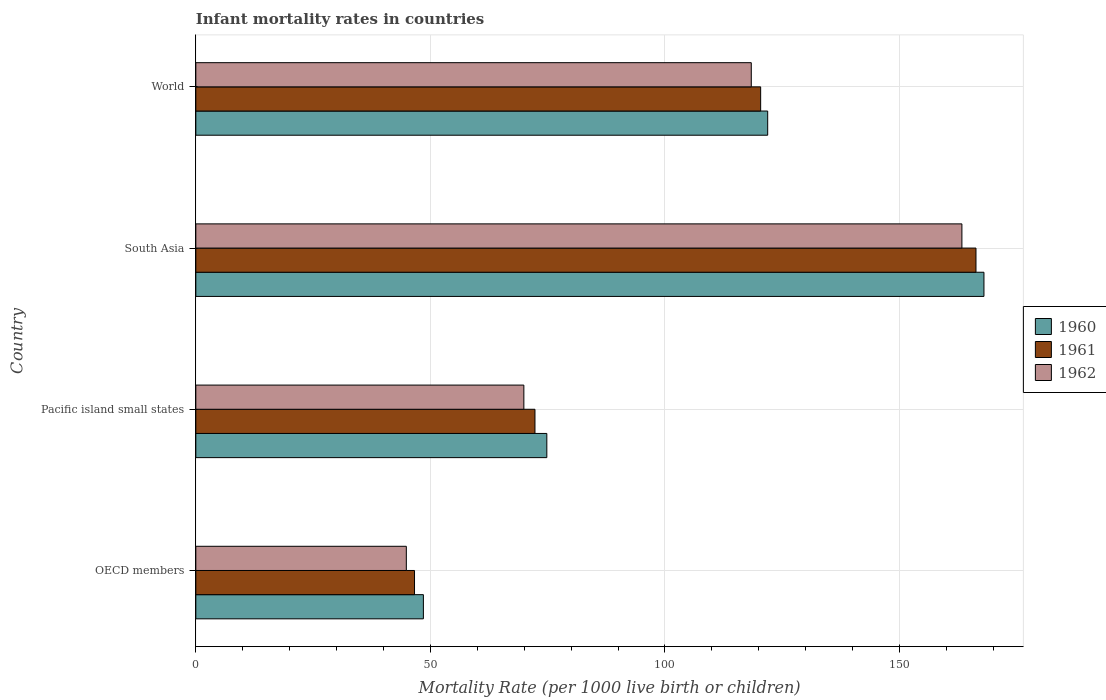How many different coloured bars are there?
Your answer should be compact. 3. How many groups of bars are there?
Ensure brevity in your answer.  4. Are the number of bars per tick equal to the number of legend labels?
Make the answer very short. Yes. How many bars are there on the 4th tick from the bottom?
Keep it short and to the point. 3. What is the label of the 4th group of bars from the top?
Make the answer very short. OECD members. What is the infant mortality rate in 1962 in World?
Provide a succinct answer. 118.4. Across all countries, what is the maximum infant mortality rate in 1960?
Your response must be concise. 168. Across all countries, what is the minimum infant mortality rate in 1960?
Your response must be concise. 48.51. In which country was the infant mortality rate in 1962 maximum?
Your answer should be compact. South Asia. In which country was the infant mortality rate in 1961 minimum?
Keep it short and to the point. OECD members. What is the total infant mortality rate in 1962 in the graph?
Offer a very short reply. 396.5. What is the difference between the infant mortality rate in 1960 in OECD members and that in South Asia?
Your response must be concise. -119.49. What is the difference between the infant mortality rate in 1960 in Pacific island small states and the infant mortality rate in 1961 in World?
Offer a terse response. -45.58. What is the average infant mortality rate in 1961 per country?
Offer a terse response. 101.4. What is the ratio of the infant mortality rate in 1961 in OECD members to that in Pacific island small states?
Offer a terse response. 0.64. What is the difference between the highest and the second highest infant mortality rate in 1962?
Provide a succinct answer. 44.9. What is the difference between the highest and the lowest infant mortality rate in 1960?
Ensure brevity in your answer.  119.49. In how many countries, is the infant mortality rate in 1961 greater than the average infant mortality rate in 1961 taken over all countries?
Offer a terse response. 2. What does the 2nd bar from the top in Pacific island small states represents?
Your answer should be very brief. 1961. Is it the case that in every country, the sum of the infant mortality rate in 1961 and infant mortality rate in 1962 is greater than the infant mortality rate in 1960?
Ensure brevity in your answer.  Yes. Are all the bars in the graph horizontal?
Provide a succinct answer. Yes. How many countries are there in the graph?
Offer a very short reply. 4. Does the graph contain any zero values?
Keep it short and to the point. No. How are the legend labels stacked?
Provide a short and direct response. Vertical. What is the title of the graph?
Your response must be concise. Infant mortality rates in countries. Does "1976" appear as one of the legend labels in the graph?
Offer a terse response. No. What is the label or title of the X-axis?
Provide a succinct answer. Mortality Rate (per 1000 live birth or children). What is the label or title of the Y-axis?
Your answer should be very brief. Country. What is the Mortality Rate (per 1000 live birth or children) in 1960 in OECD members?
Ensure brevity in your answer.  48.51. What is the Mortality Rate (per 1000 live birth or children) of 1961 in OECD members?
Offer a terse response. 46.61. What is the Mortality Rate (per 1000 live birth or children) of 1962 in OECD members?
Your response must be concise. 44.87. What is the Mortality Rate (per 1000 live birth or children) of 1960 in Pacific island small states?
Provide a short and direct response. 74.82. What is the Mortality Rate (per 1000 live birth or children) of 1961 in Pacific island small states?
Your answer should be compact. 72.29. What is the Mortality Rate (per 1000 live birth or children) in 1962 in Pacific island small states?
Make the answer very short. 69.93. What is the Mortality Rate (per 1000 live birth or children) of 1960 in South Asia?
Provide a short and direct response. 168. What is the Mortality Rate (per 1000 live birth or children) of 1961 in South Asia?
Make the answer very short. 166.3. What is the Mortality Rate (per 1000 live birth or children) of 1962 in South Asia?
Keep it short and to the point. 163.3. What is the Mortality Rate (per 1000 live birth or children) in 1960 in World?
Provide a short and direct response. 121.9. What is the Mortality Rate (per 1000 live birth or children) of 1961 in World?
Give a very brief answer. 120.4. What is the Mortality Rate (per 1000 live birth or children) of 1962 in World?
Ensure brevity in your answer.  118.4. Across all countries, what is the maximum Mortality Rate (per 1000 live birth or children) in 1960?
Your answer should be very brief. 168. Across all countries, what is the maximum Mortality Rate (per 1000 live birth or children) in 1961?
Offer a very short reply. 166.3. Across all countries, what is the maximum Mortality Rate (per 1000 live birth or children) in 1962?
Offer a very short reply. 163.3. Across all countries, what is the minimum Mortality Rate (per 1000 live birth or children) in 1960?
Ensure brevity in your answer.  48.51. Across all countries, what is the minimum Mortality Rate (per 1000 live birth or children) of 1961?
Your answer should be compact. 46.61. Across all countries, what is the minimum Mortality Rate (per 1000 live birth or children) of 1962?
Provide a succinct answer. 44.87. What is the total Mortality Rate (per 1000 live birth or children) in 1960 in the graph?
Provide a short and direct response. 413.23. What is the total Mortality Rate (per 1000 live birth or children) in 1961 in the graph?
Provide a succinct answer. 405.61. What is the total Mortality Rate (per 1000 live birth or children) in 1962 in the graph?
Your answer should be very brief. 396.5. What is the difference between the Mortality Rate (per 1000 live birth or children) in 1960 in OECD members and that in Pacific island small states?
Your answer should be very brief. -26.31. What is the difference between the Mortality Rate (per 1000 live birth or children) in 1961 in OECD members and that in Pacific island small states?
Ensure brevity in your answer.  -25.68. What is the difference between the Mortality Rate (per 1000 live birth or children) of 1962 in OECD members and that in Pacific island small states?
Provide a succinct answer. -25.05. What is the difference between the Mortality Rate (per 1000 live birth or children) in 1960 in OECD members and that in South Asia?
Offer a very short reply. -119.49. What is the difference between the Mortality Rate (per 1000 live birth or children) of 1961 in OECD members and that in South Asia?
Offer a terse response. -119.69. What is the difference between the Mortality Rate (per 1000 live birth or children) of 1962 in OECD members and that in South Asia?
Make the answer very short. -118.43. What is the difference between the Mortality Rate (per 1000 live birth or children) of 1960 in OECD members and that in World?
Your answer should be compact. -73.39. What is the difference between the Mortality Rate (per 1000 live birth or children) of 1961 in OECD members and that in World?
Make the answer very short. -73.79. What is the difference between the Mortality Rate (per 1000 live birth or children) in 1962 in OECD members and that in World?
Keep it short and to the point. -73.53. What is the difference between the Mortality Rate (per 1000 live birth or children) in 1960 in Pacific island small states and that in South Asia?
Your response must be concise. -93.18. What is the difference between the Mortality Rate (per 1000 live birth or children) of 1961 in Pacific island small states and that in South Asia?
Make the answer very short. -94.01. What is the difference between the Mortality Rate (per 1000 live birth or children) of 1962 in Pacific island small states and that in South Asia?
Offer a very short reply. -93.37. What is the difference between the Mortality Rate (per 1000 live birth or children) of 1960 in Pacific island small states and that in World?
Make the answer very short. -47.08. What is the difference between the Mortality Rate (per 1000 live birth or children) of 1961 in Pacific island small states and that in World?
Give a very brief answer. -48.11. What is the difference between the Mortality Rate (per 1000 live birth or children) of 1962 in Pacific island small states and that in World?
Your answer should be very brief. -48.47. What is the difference between the Mortality Rate (per 1000 live birth or children) in 1960 in South Asia and that in World?
Ensure brevity in your answer.  46.1. What is the difference between the Mortality Rate (per 1000 live birth or children) of 1961 in South Asia and that in World?
Ensure brevity in your answer.  45.9. What is the difference between the Mortality Rate (per 1000 live birth or children) of 1962 in South Asia and that in World?
Give a very brief answer. 44.9. What is the difference between the Mortality Rate (per 1000 live birth or children) in 1960 in OECD members and the Mortality Rate (per 1000 live birth or children) in 1961 in Pacific island small states?
Your response must be concise. -23.78. What is the difference between the Mortality Rate (per 1000 live birth or children) of 1960 in OECD members and the Mortality Rate (per 1000 live birth or children) of 1962 in Pacific island small states?
Your answer should be very brief. -21.42. What is the difference between the Mortality Rate (per 1000 live birth or children) of 1961 in OECD members and the Mortality Rate (per 1000 live birth or children) of 1962 in Pacific island small states?
Keep it short and to the point. -23.31. What is the difference between the Mortality Rate (per 1000 live birth or children) in 1960 in OECD members and the Mortality Rate (per 1000 live birth or children) in 1961 in South Asia?
Ensure brevity in your answer.  -117.79. What is the difference between the Mortality Rate (per 1000 live birth or children) of 1960 in OECD members and the Mortality Rate (per 1000 live birth or children) of 1962 in South Asia?
Provide a short and direct response. -114.79. What is the difference between the Mortality Rate (per 1000 live birth or children) of 1961 in OECD members and the Mortality Rate (per 1000 live birth or children) of 1962 in South Asia?
Keep it short and to the point. -116.69. What is the difference between the Mortality Rate (per 1000 live birth or children) in 1960 in OECD members and the Mortality Rate (per 1000 live birth or children) in 1961 in World?
Your response must be concise. -71.89. What is the difference between the Mortality Rate (per 1000 live birth or children) of 1960 in OECD members and the Mortality Rate (per 1000 live birth or children) of 1962 in World?
Offer a terse response. -69.89. What is the difference between the Mortality Rate (per 1000 live birth or children) of 1961 in OECD members and the Mortality Rate (per 1000 live birth or children) of 1962 in World?
Your answer should be very brief. -71.79. What is the difference between the Mortality Rate (per 1000 live birth or children) of 1960 in Pacific island small states and the Mortality Rate (per 1000 live birth or children) of 1961 in South Asia?
Your response must be concise. -91.48. What is the difference between the Mortality Rate (per 1000 live birth or children) of 1960 in Pacific island small states and the Mortality Rate (per 1000 live birth or children) of 1962 in South Asia?
Offer a terse response. -88.48. What is the difference between the Mortality Rate (per 1000 live birth or children) of 1961 in Pacific island small states and the Mortality Rate (per 1000 live birth or children) of 1962 in South Asia?
Your answer should be compact. -91.01. What is the difference between the Mortality Rate (per 1000 live birth or children) in 1960 in Pacific island small states and the Mortality Rate (per 1000 live birth or children) in 1961 in World?
Make the answer very short. -45.58. What is the difference between the Mortality Rate (per 1000 live birth or children) in 1960 in Pacific island small states and the Mortality Rate (per 1000 live birth or children) in 1962 in World?
Give a very brief answer. -43.58. What is the difference between the Mortality Rate (per 1000 live birth or children) of 1961 in Pacific island small states and the Mortality Rate (per 1000 live birth or children) of 1962 in World?
Provide a succinct answer. -46.11. What is the difference between the Mortality Rate (per 1000 live birth or children) of 1960 in South Asia and the Mortality Rate (per 1000 live birth or children) of 1961 in World?
Your answer should be very brief. 47.6. What is the difference between the Mortality Rate (per 1000 live birth or children) of 1960 in South Asia and the Mortality Rate (per 1000 live birth or children) of 1962 in World?
Make the answer very short. 49.6. What is the difference between the Mortality Rate (per 1000 live birth or children) of 1961 in South Asia and the Mortality Rate (per 1000 live birth or children) of 1962 in World?
Make the answer very short. 47.9. What is the average Mortality Rate (per 1000 live birth or children) of 1960 per country?
Offer a terse response. 103.31. What is the average Mortality Rate (per 1000 live birth or children) in 1961 per country?
Give a very brief answer. 101.4. What is the average Mortality Rate (per 1000 live birth or children) in 1962 per country?
Keep it short and to the point. 99.12. What is the difference between the Mortality Rate (per 1000 live birth or children) of 1960 and Mortality Rate (per 1000 live birth or children) of 1961 in OECD members?
Make the answer very short. 1.89. What is the difference between the Mortality Rate (per 1000 live birth or children) in 1960 and Mortality Rate (per 1000 live birth or children) in 1962 in OECD members?
Your answer should be very brief. 3.64. What is the difference between the Mortality Rate (per 1000 live birth or children) in 1961 and Mortality Rate (per 1000 live birth or children) in 1962 in OECD members?
Your answer should be compact. 1.74. What is the difference between the Mortality Rate (per 1000 live birth or children) in 1960 and Mortality Rate (per 1000 live birth or children) in 1961 in Pacific island small states?
Provide a succinct answer. 2.53. What is the difference between the Mortality Rate (per 1000 live birth or children) of 1960 and Mortality Rate (per 1000 live birth or children) of 1962 in Pacific island small states?
Your response must be concise. 4.89. What is the difference between the Mortality Rate (per 1000 live birth or children) in 1961 and Mortality Rate (per 1000 live birth or children) in 1962 in Pacific island small states?
Make the answer very short. 2.37. What is the difference between the Mortality Rate (per 1000 live birth or children) of 1960 and Mortality Rate (per 1000 live birth or children) of 1962 in South Asia?
Offer a terse response. 4.7. What is the difference between the Mortality Rate (per 1000 live birth or children) in 1960 and Mortality Rate (per 1000 live birth or children) in 1962 in World?
Your response must be concise. 3.5. What is the ratio of the Mortality Rate (per 1000 live birth or children) of 1960 in OECD members to that in Pacific island small states?
Provide a short and direct response. 0.65. What is the ratio of the Mortality Rate (per 1000 live birth or children) of 1961 in OECD members to that in Pacific island small states?
Your answer should be compact. 0.64. What is the ratio of the Mortality Rate (per 1000 live birth or children) in 1962 in OECD members to that in Pacific island small states?
Your response must be concise. 0.64. What is the ratio of the Mortality Rate (per 1000 live birth or children) in 1960 in OECD members to that in South Asia?
Keep it short and to the point. 0.29. What is the ratio of the Mortality Rate (per 1000 live birth or children) in 1961 in OECD members to that in South Asia?
Your answer should be very brief. 0.28. What is the ratio of the Mortality Rate (per 1000 live birth or children) of 1962 in OECD members to that in South Asia?
Your response must be concise. 0.27. What is the ratio of the Mortality Rate (per 1000 live birth or children) in 1960 in OECD members to that in World?
Your answer should be very brief. 0.4. What is the ratio of the Mortality Rate (per 1000 live birth or children) of 1961 in OECD members to that in World?
Your answer should be compact. 0.39. What is the ratio of the Mortality Rate (per 1000 live birth or children) in 1962 in OECD members to that in World?
Your response must be concise. 0.38. What is the ratio of the Mortality Rate (per 1000 live birth or children) in 1960 in Pacific island small states to that in South Asia?
Give a very brief answer. 0.45. What is the ratio of the Mortality Rate (per 1000 live birth or children) of 1961 in Pacific island small states to that in South Asia?
Ensure brevity in your answer.  0.43. What is the ratio of the Mortality Rate (per 1000 live birth or children) in 1962 in Pacific island small states to that in South Asia?
Ensure brevity in your answer.  0.43. What is the ratio of the Mortality Rate (per 1000 live birth or children) in 1960 in Pacific island small states to that in World?
Your response must be concise. 0.61. What is the ratio of the Mortality Rate (per 1000 live birth or children) of 1961 in Pacific island small states to that in World?
Make the answer very short. 0.6. What is the ratio of the Mortality Rate (per 1000 live birth or children) of 1962 in Pacific island small states to that in World?
Your answer should be compact. 0.59. What is the ratio of the Mortality Rate (per 1000 live birth or children) of 1960 in South Asia to that in World?
Your answer should be very brief. 1.38. What is the ratio of the Mortality Rate (per 1000 live birth or children) of 1961 in South Asia to that in World?
Give a very brief answer. 1.38. What is the ratio of the Mortality Rate (per 1000 live birth or children) of 1962 in South Asia to that in World?
Provide a short and direct response. 1.38. What is the difference between the highest and the second highest Mortality Rate (per 1000 live birth or children) of 1960?
Provide a succinct answer. 46.1. What is the difference between the highest and the second highest Mortality Rate (per 1000 live birth or children) of 1961?
Ensure brevity in your answer.  45.9. What is the difference between the highest and the second highest Mortality Rate (per 1000 live birth or children) of 1962?
Your response must be concise. 44.9. What is the difference between the highest and the lowest Mortality Rate (per 1000 live birth or children) in 1960?
Offer a terse response. 119.49. What is the difference between the highest and the lowest Mortality Rate (per 1000 live birth or children) in 1961?
Your answer should be very brief. 119.69. What is the difference between the highest and the lowest Mortality Rate (per 1000 live birth or children) in 1962?
Give a very brief answer. 118.43. 